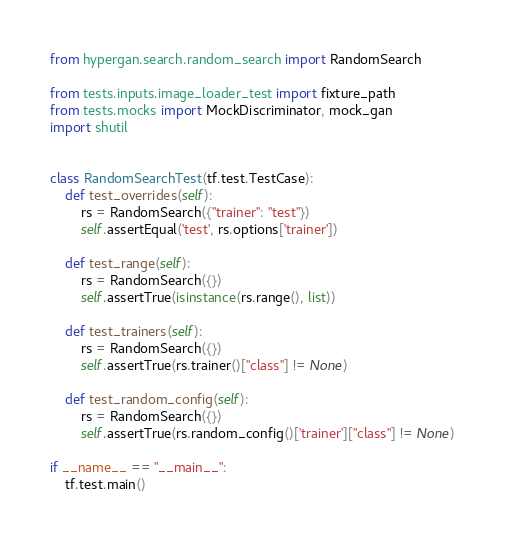<code> <loc_0><loc_0><loc_500><loc_500><_Python_>from hypergan.search.random_search import RandomSearch

from tests.inputs.image_loader_test import fixture_path
from tests.mocks import MockDiscriminator, mock_gan
import shutil


class RandomSearchTest(tf.test.TestCase):
    def test_overrides(self):
        rs = RandomSearch({"trainer": "test"})
        self.assertEqual('test', rs.options['trainer'])

    def test_range(self):
        rs = RandomSearch({})
        self.assertTrue(isinstance(rs.range(), list))

    def test_trainers(self):
        rs = RandomSearch({})
        self.assertTrue(rs.trainer()["class"] != None)

    def test_random_config(self):
        rs = RandomSearch({})
        self.assertTrue(rs.random_config()['trainer']["class"] != None)

if __name__ == "__main__":
    tf.test.main()
</code> 